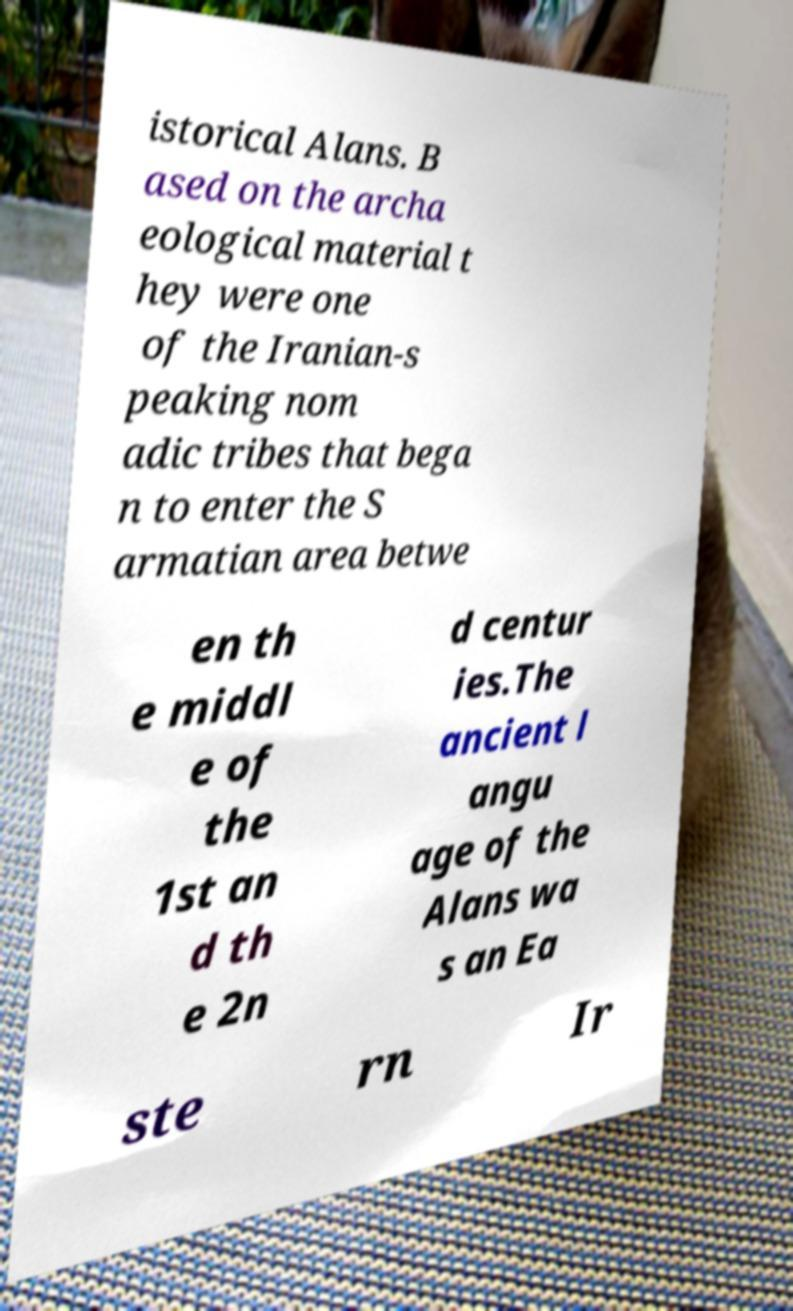Could you extract and type out the text from this image? istorical Alans. B ased on the archa eological material t hey were one of the Iranian-s peaking nom adic tribes that bega n to enter the S armatian area betwe en th e middl e of the 1st an d th e 2n d centur ies.The ancient l angu age of the Alans wa s an Ea ste rn Ir 